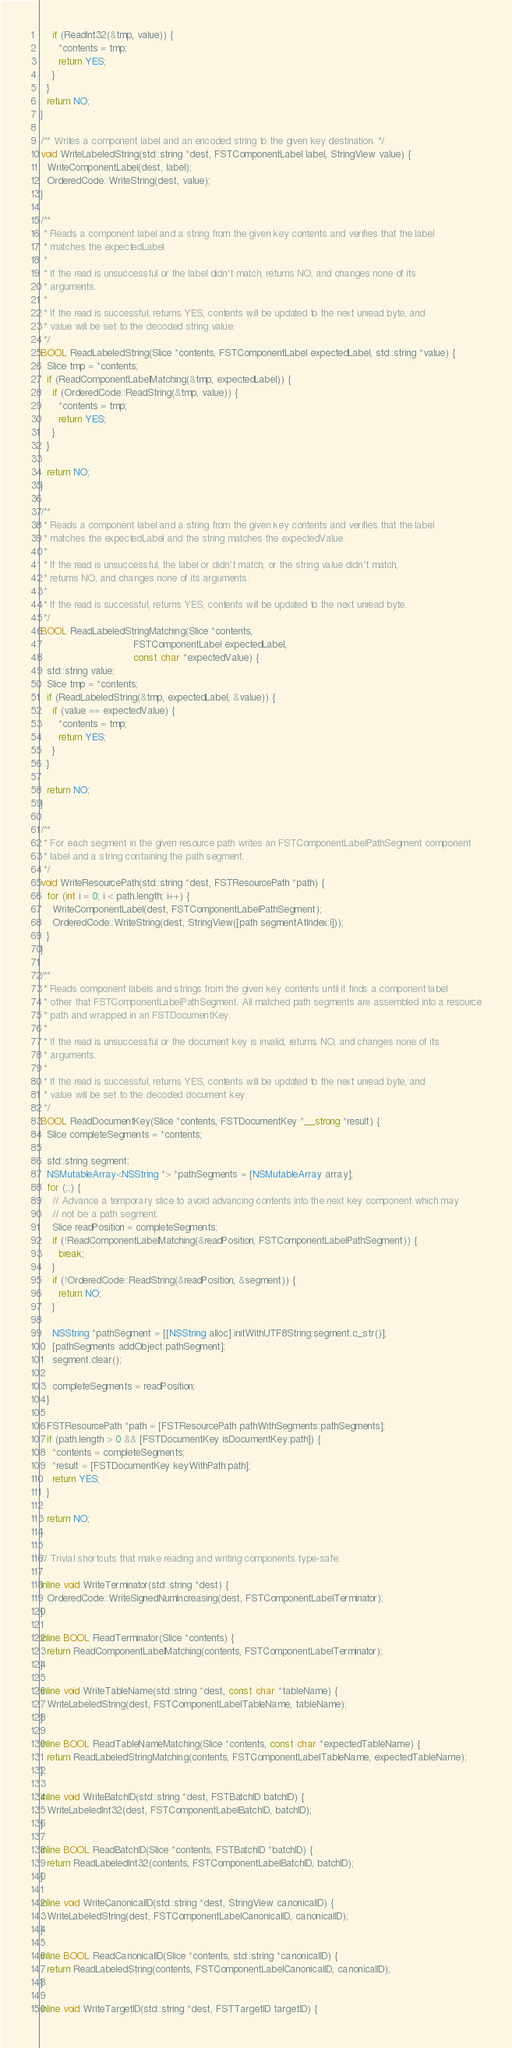Convert code to text. <code><loc_0><loc_0><loc_500><loc_500><_ObjectiveC_>    if (ReadInt32(&tmp, value)) {
      *contents = tmp;
      return YES;
    }
  }
  return NO;
}

/** Writes a component label and an encoded string to the given key destination. */
void WriteLabeledString(std::string *dest, FSTComponentLabel label, StringView value) {
  WriteComponentLabel(dest, label);
  OrderedCode::WriteString(dest, value);
}

/**
 * Reads a component label and a string from the given key contents and verifies that the label
 * matches the expectedLabel.
 *
 * If the read is unsuccessful or the label didn't match, returns NO, and changes none of its
 * arguments.
 *
 * If the read is successful, returns YES, contents will be updated to the next unread byte, and
 * value will be set to the decoded string value.
 */
BOOL ReadLabeledString(Slice *contents, FSTComponentLabel expectedLabel, std::string *value) {
  Slice tmp = *contents;
  if (ReadComponentLabelMatching(&tmp, expectedLabel)) {
    if (OrderedCode::ReadString(&tmp, value)) {
      *contents = tmp;
      return YES;
    }
  }

  return NO;
}

/**
 * Reads a component label and a string from the given key contents and verifies that the label
 * matches the expectedLabel and the string matches the expectedValue.
 *
 * If the read is unsuccessful, the label or didn't match, or the string value didn't match,
 * returns NO, and changes none of its arguments.
 *
 * If the read is successful, returns YES, contents will be updated to the next unread byte.
 */
BOOL ReadLabeledStringMatching(Slice *contents,
                               FSTComponentLabel expectedLabel,
                               const char *expectedValue) {
  std::string value;
  Slice tmp = *contents;
  if (ReadLabeledString(&tmp, expectedLabel, &value)) {
    if (value == expectedValue) {
      *contents = tmp;
      return YES;
    }
  }

  return NO;
}

/**
 * For each segment in the given resource path writes an FSTComponentLabelPathSegment component
 * label and a string containing the path segment.
 */
void WriteResourcePath(std::string *dest, FSTResourcePath *path) {
  for (int i = 0; i < path.length; i++) {
    WriteComponentLabel(dest, FSTComponentLabelPathSegment);
    OrderedCode::WriteString(dest, StringView([path segmentAtIndex:i]));
  }
}

/**
 * Reads component labels and strings from the given key contents until it finds a component label
 * other that FSTComponentLabelPathSegment. All matched path segments are assembled into a resource
 * path and wrapped in an FSTDocumentKey.
 *
 * If the read is unsuccessful or the document key is invalid, returns NO, and changes none of its
 * arguments.
 *
 * If the read is successful, returns YES, contents will be updated to the next unread byte, and
 * value will be set to the decoded document key.
 */
BOOL ReadDocumentKey(Slice *contents, FSTDocumentKey *__strong *result) {
  Slice completeSegments = *contents;

  std::string segment;
  NSMutableArray<NSString *> *pathSegments = [NSMutableArray array];
  for (;;) {
    // Advance a temporary slice to avoid advancing contents into the next key component which may
    // not be a path segment.
    Slice readPosition = completeSegments;
    if (!ReadComponentLabelMatching(&readPosition, FSTComponentLabelPathSegment)) {
      break;
    }
    if (!OrderedCode::ReadString(&readPosition, &segment)) {
      return NO;
    }

    NSString *pathSegment = [[NSString alloc] initWithUTF8String:segment.c_str()];
    [pathSegments addObject:pathSegment];
    segment.clear();

    completeSegments = readPosition;
  }

  FSTResourcePath *path = [FSTResourcePath pathWithSegments:pathSegments];
  if (path.length > 0 && [FSTDocumentKey isDocumentKey:path]) {
    *contents = completeSegments;
    *result = [FSTDocumentKey keyWithPath:path];
    return YES;
  }

  return NO;
}

// Trivial shortcuts that make reading and writing components type-safe.

inline void WriteTerminator(std::string *dest) {
  OrderedCode::WriteSignedNumIncreasing(dest, FSTComponentLabelTerminator);
}

inline BOOL ReadTerminator(Slice *contents) {
  return ReadComponentLabelMatching(contents, FSTComponentLabelTerminator);
}

inline void WriteTableName(std::string *dest, const char *tableName) {
  WriteLabeledString(dest, FSTComponentLabelTableName, tableName);
}

inline BOOL ReadTableNameMatching(Slice *contents, const char *expectedTableName) {
  return ReadLabeledStringMatching(contents, FSTComponentLabelTableName, expectedTableName);
}

inline void WriteBatchID(std::string *dest, FSTBatchID batchID) {
  WriteLabeledInt32(dest, FSTComponentLabelBatchID, batchID);
}

inline BOOL ReadBatchID(Slice *contents, FSTBatchID *batchID) {
  return ReadLabeledInt32(contents, FSTComponentLabelBatchID, batchID);
}

inline void WriteCanonicalID(std::string *dest, StringView canonicalID) {
  WriteLabeledString(dest, FSTComponentLabelCanonicalID, canonicalID);
}

inline BOOL ReadCanonicalID(Slice *contents, std::string *canonicalID) {
  return ReadLabeledString(contents, FSTComponentLabelCanonicalID, canonicalID);
}

inline void WriteTargetID(std::string *dest, FSTTargetID targetID) {</code> 